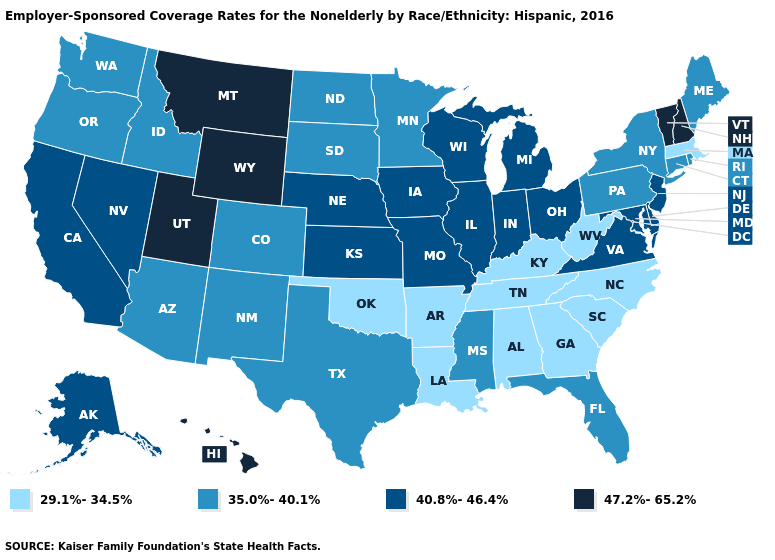Among the states that border Nebraska , which have the highest value?
Write a very short answer. Wyoming. Name the states that have a value in the range 35.0%-40.1%?
Quick response, please. Arizona, Colorado, Connecticut, Florida, Idaho, Maine, Minnesota, Mississippi, New Mexico, New York, North Dakota, Oregon, Pennsylvania, Rhode Island, South Dakota, Texas, Washington. Name the states that have a value in the range 29.1%-34.5%?
Concise answer only. Alabama, Arkansas, Georgia, Kentucky, Louisiana, Massachusetts, North Carolina, Oklahoma, South Carolina, Tennessee, West Virginia. What is the lowest value in the USA?
Answer briefly. 29.1%-34.5%. What is the value of Ohio?
Quick response, please. 40.8%-46.4%. What is the value of Tennessee?
Quick response, please. 29.1%-34.5%. Name the states that have a value in the range 35.0%-40.1%?
Short answer required. Arizona, Colorado, Connecticut, Florida, Idaho, Maine, Minnesota, Mississippi, New Mexico, New York, North Dakota, Oregon, Pennsylvania, Rhode Island, South Dakota, Texas, Washington. Name the states that have a value in the range 40.8%-46.4%?
Write a very short answer. Alaska, California, Delaware, Illinois, Indiana, Iowa, Kansas, Maryland, Michigan, Missouri, Nebraska, Nevada, New Jersey, Ohio, Virginia, Wisconsin. What is the lowest value in the USA?
Give a very brief answer. 29.1%-34.5%. What is the value of New York?
Concise answer only. 35.0%-40.1%. Name the states that have a value in the range 35.0%-40.1%?
Be succinct. Arizona, Colorado, Connecticut, Florida, Idaho, Maine, Minnesota, Mississippi, New Mexico, New York, North Dakota, Oregon, Pennsylvania, Rhode Island, South Dakota, Texas, Washington. Among the states that border West Virginia , does Maryland have the highest value?
Concise answer only. Yes. Which states have the lowest value in the MidWest?
Give a very brief answer. Minnesota, North Dakota, South Dakota. Does the first symbol in the legend represent the smallest category?
Quick response, please. Yes. What is the value of Arizona?
Write a very short answer. 35.0%-40.1%. 